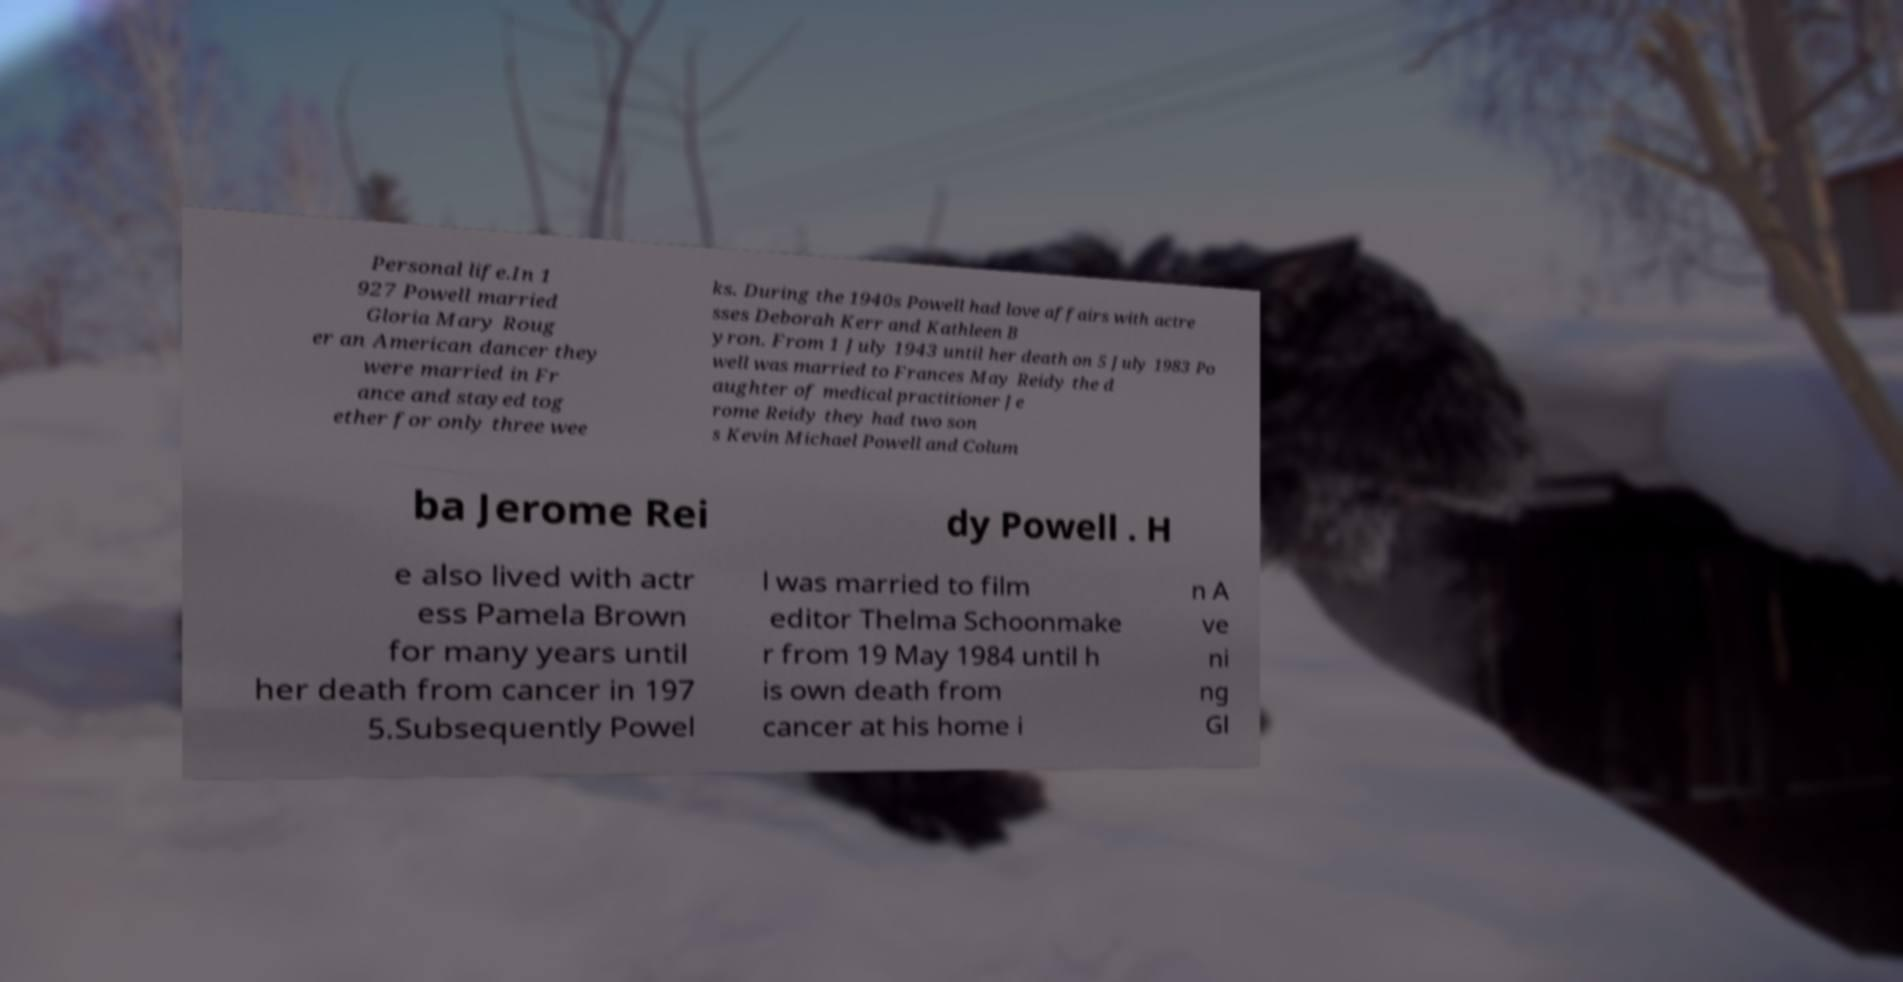I need the written content from this picture converted into text. Can you do that? Personal life.In 1 927 Powell married Gloria Mary Roug er an American dancer they were married in Fr ance and stayed tog ether for only three wee ks. During the 1940s Powell had love affairs with actre sses Deborah Kerr and Kathleen B yron. From 1 July 1943 until her death on 5 July 1983 Po well was married to Frances May Reidy the d aughter of medical practitioner Je rome Reidy they had two son s Kevin Michael Powell and Colum ba Jerome Rei dy Powell . H e also lived with actr ess Pamela Brown for many years until her death from cancer in 197 5.Subsequently Powel l was married to film editor Thelma Schoonmake r from 19 May 1984 until h is own death from cancer at his home i n A ve ni ng Gl 